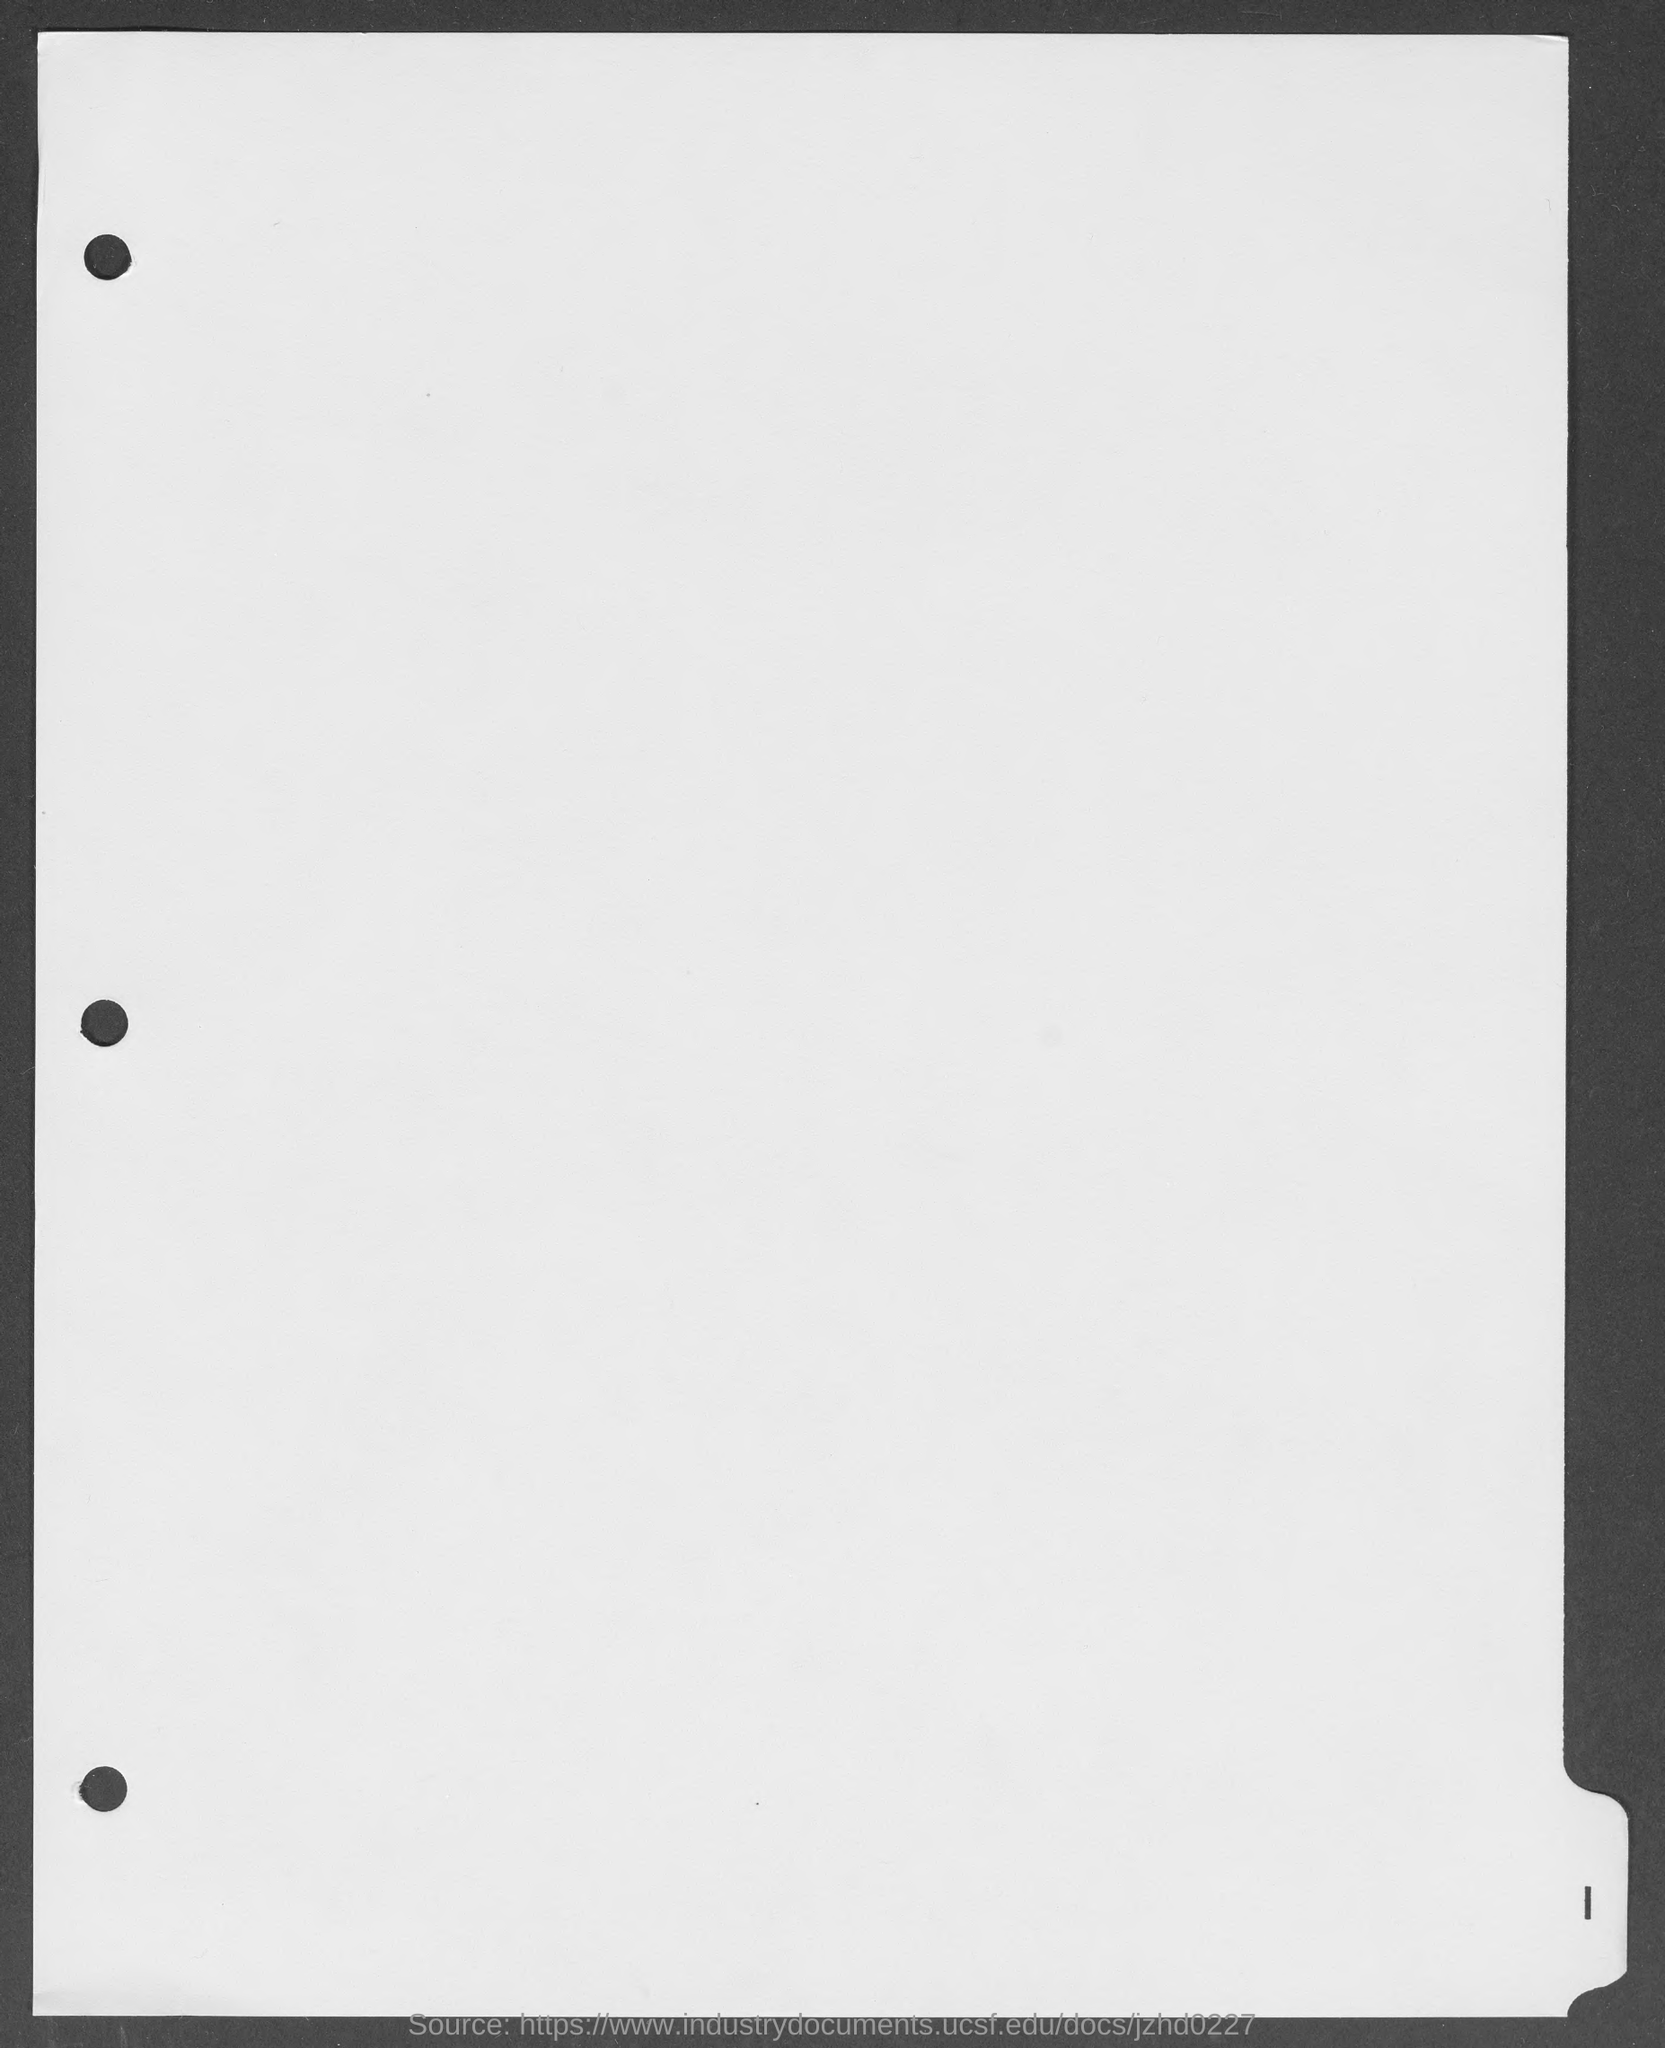Identify some key points in this picture. The page number mentioned at the right bottom of the page is 1. 